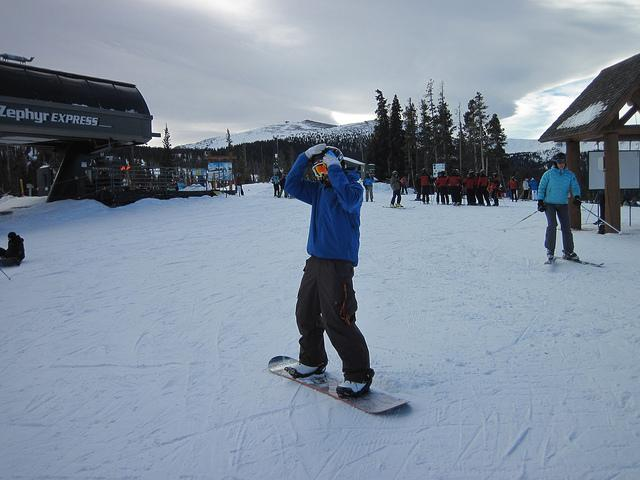What do these men plan to do here? Please explain your reasoning. ski. This is a ski resort and that's one of the things people come up here to do. 